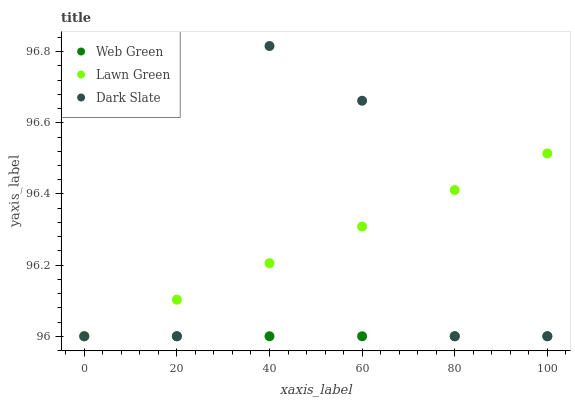Does Web Green have the minimum area under the curve?
Answer yes or no. Yes. Does Dark Slate have the maximum area under the curve?
Answer yes or no. Yes. Does Dark Slate have the minimum area under the curve?
Answer yes or no. No. Does Web Green have the maximum area under the curve?
Answer yes or no. No. Is Web Green the smoothest?
Answer yes or no. Yes. Is Dark Slate the roughest?
Answer yes or no. Yes. Is Dark Slate the smoothest?
Answer yes or no. No. Is Web Green the roughest?
Answer yes or no. No. Does Lawn Green have the lowest value?
Answer yes or no. Yes. Does Dark Slate have the highest value?
Answer yes or no. Yes. Does Web Green have the highest value?
Answer yes or no. No. Does Lawn Green intersect Web Green?
Answer yes or no. Yes. Is Lawn Green less than Web Green?
Answer yes or no. No. Is Lawn Green greater than Web Green?
Answer yes or no. No. 